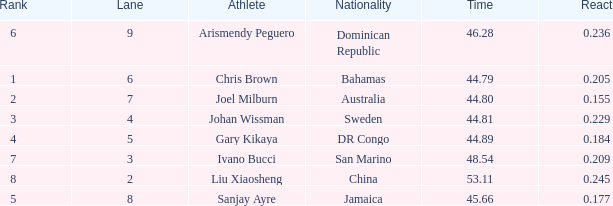How many total Time listings have a 0.209 React entry and a Rank that is greater than 7? 0.0. 